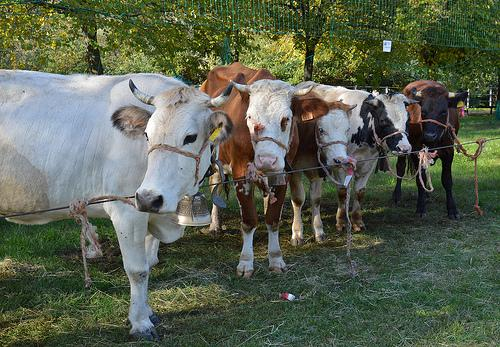Question: when was the picture taken?
Choices:
A. During the day.
B. At night.
C. Lunchtime.
D. Yesterday.
Answer with the letter. Answer: A Question: where was the picture taken?
Choices:
A. In the back yard.
B. Grandma's house.
C. On a farm.
D. California.
Answer with the letter. Answer: C Question: how many cattle is in the picture?
Choices:
A. Five.
B. Four.
C. Two.
D. One.
Answer with the letter. Answer: A 